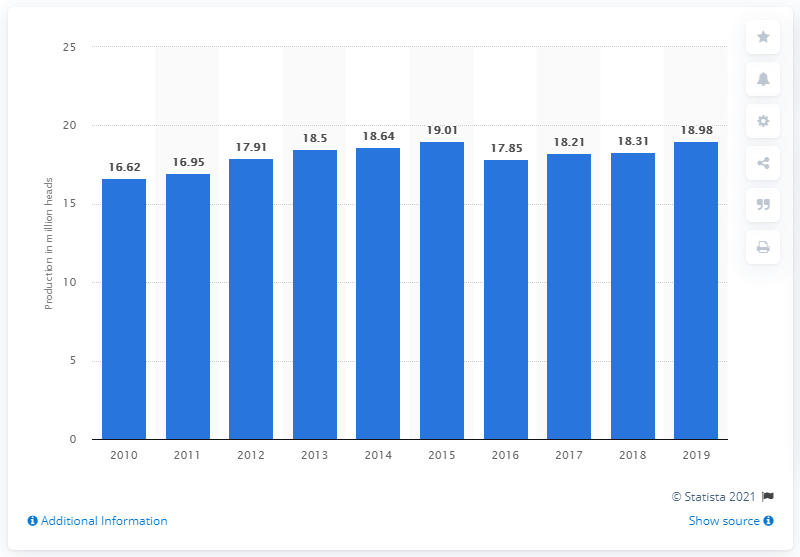Indicate a few pertinent items in this graphic. In 2019, a total of 18,980 goats were produced in Indonesia. 